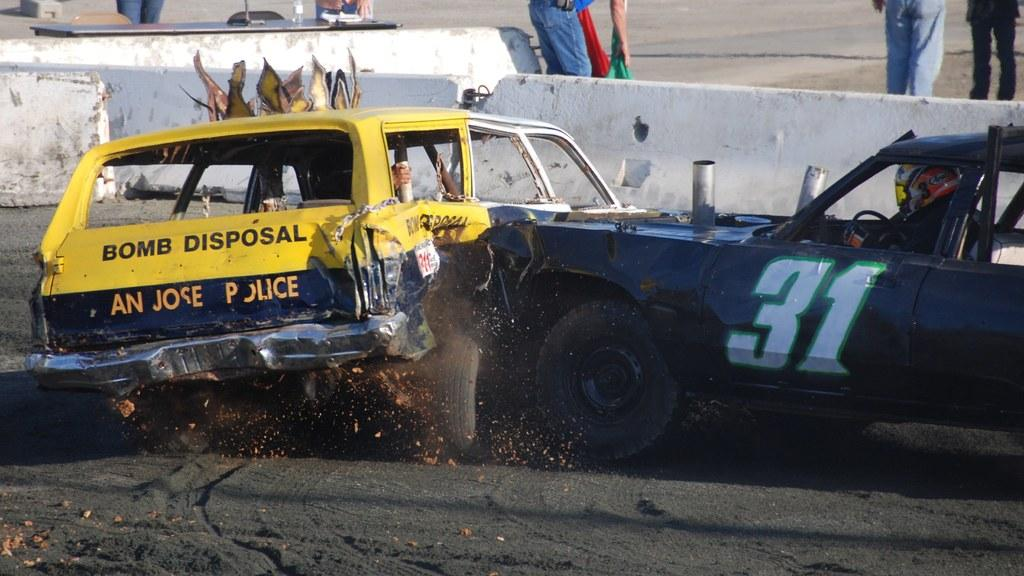What can be seen on the path in the image? There are two vehicles on the path. What is visible in the background of the image? There is a wall and people standing in the background of the image. What star can be seen shining brightly in the image? There is no star visible in the image; it is focused on the path and the background. 